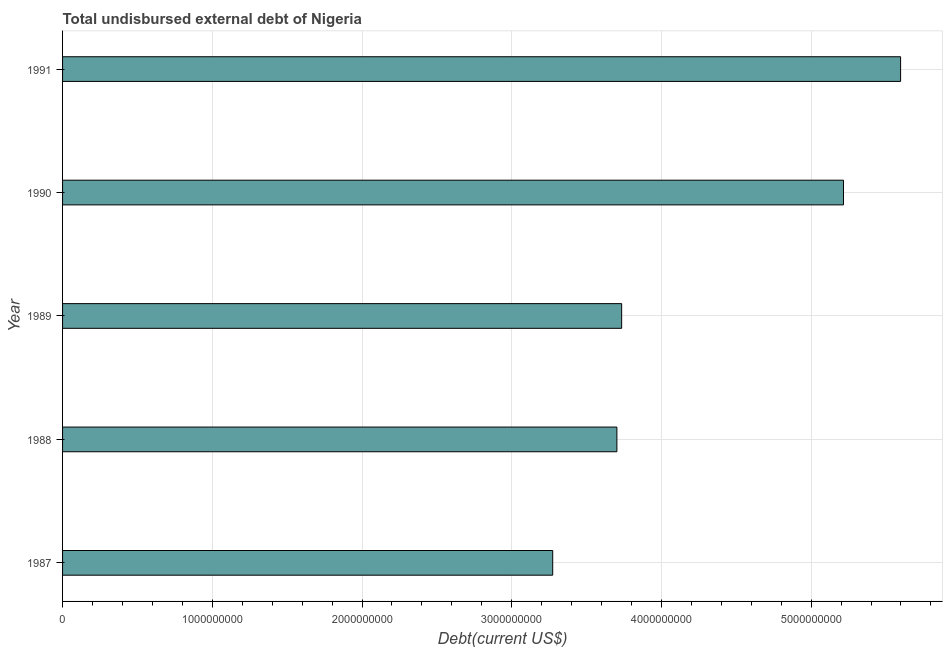Does the graph contain any zero values?
Your response must be concise. No. What is the title of the graph?
Provide a succinct answer. Total undisbursed external debt of Nigeria. What is the label or title of the X-axis?
Your answer should be very brief. Debt(current US$). What is the label or title of the Y-axis?
Ensure brevity in your answer.  Year. What is the total debt in 1990?
Ensure brevity in your answer.  5.22e+09. Across all years, what is the maximum total debt?
Your answer should be very brief. 5.60e+09. Across all years, what is the minimum total debt?
Keep it short and to the point. 3.27e+09. In which year was the total debt maximum?
Ensure brevity in your answer.  1991. In which year was the total debt minimum?
Your answer should be very brief. 1987. What is the sum of the total debt?
Provide a succinct answer. 2.15e+1. What is the difference between the total debt in 1989 and 1990?
Your response must be concise. -1.48e+09. What is the average total debt per year?
Your answer should be very brief. 4.30e+09. What is the median total debt?
Keep it short and to the point. 3.73e+09. In how many years, is the total debt greater than 4800000000 US$?
Your response must be concise. 2. What is the ratio of the total debt in 1987 to that in 1991?
Offer a very short reply. 0.58. What is the difference between the highest and the second highest total debt?
Your answer should be very brief. 3.81e+08. Is the sum of the total debt in 1989 and 1990 greater than the maximum total debt across all years?
Ensure brevity in your answer.  Yes. What is the difference between the highest and the lowest total debt?
Your response must be concise. 2.32e+09. In how many years, is the total debt greater than the average total debt taken over all years?
Provide a short and direct response. 2. Are all the bars in the graph horizontal?
Make the answer very short. Yes. How many years are there in the graph?
Offer a very short reply. 5. What is the difference between two consecutive major ticks on the X-axis?
Provide a short and direct response. 1.00e+09. Are the values on the major ticks of X-axis written in scientific E-notation?
Make the answer very short. No. What is the Debt(current US$) in 1987?
Your answer should be very brief. 3.27e+09. What is the Debt(current US$) in 1988?
Ensure brevity in your answer.  3.70e+09. What is the Debt(current US$) in 1989?
Your answer should be compact. 3.73e+09. What is the Debt(current US$) of 1990?
Ensure brevity in your answer.  5.22e+09. What is the Debt(current US$) of 1991?
Your answer should be very brief. 5.60e+09. What is the difference between the Debt(current US$) in 1987 and 1988?
Your answer should be compact. -4.29e+08. What is the difference between the Debt(current US$) in 1987 and 1989?
Ensure brevity in your answer.  -4.61e+08. What is the difference between the Debt(current US$) in 1987 and 1990?
Provide a succinct answer. -1.94e+09. What is the difference between the Debt(current US$) in 1987 and 1991?
Ensure brevity in your answer.  -2.32e+09. What is the difference between the Debt(current US$) in 1988 and 1989?
Give a very brief answer. -3.19e+07. What is the difference between the Debt(current US$) in 1988 and 1990?
Ensure brevity in your answer.  -1.51e+09. What is the difference between the Debt(current US$) in 1988 and 1991?
Provide a short and direct response. -1.89e+09. What is the difference between the Debt(current US$) in 1989 and 1990?
Offer a very short reply. -1.48e+09. What is the difference between the Debt(current US$) in 1989 and 1991?
Give a very brief answer. -1.86e+09. What is the difference between the Debt(current US$) in 1990 and 1991?
Provide a succinct answer. -3.81e+08. What is the ratio of the Debt(current US$) in 1987 to that in 1988?
Your answer should be compact. 0.88. What is the ratio of the Debt(current US$) in 1987 to that in 1989?
Offer a terse response. 0.88. What is the ratio of the Debt(current US$) in 1987 to that in 1990?
Your answer should be very brief. 0.63. What is the ratio of the Debt(current US$) in 1987 to that in 1991?
Provide a succinct answer. 0.58. What is the ratio of the Debt(current US$) in 1988 to that in 1990?
Give a very brief answer. 0.71. What is the ratio of the Debt(current US$) in 1988 to that in 1991?
Ensure brevity in your answer.  0.66. What is the ratio of the Debt(current US$) in 1989 to that in 1990?
Ensure brevity in your answer.  0.72. What is the ratio of the Debt(current US$) in 1989 to that in 1991?
Offer a terse response. 0.67. What is the ratio of the Debt(current US$) in 1990 to that in 1991?
Offer a terse response. 0.93. 